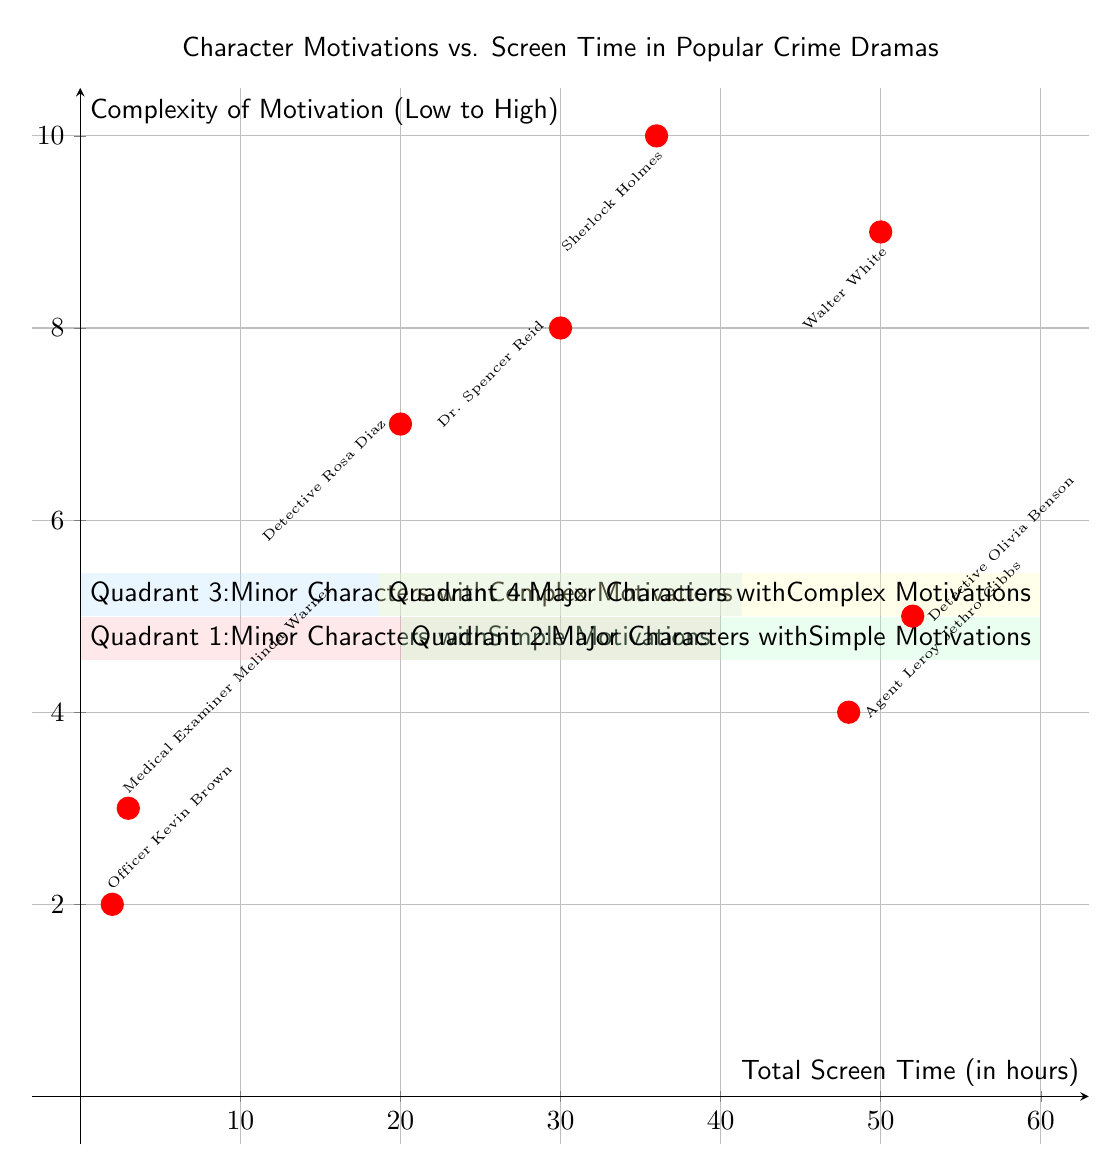What is the total screen time of Walter White? The diagram indicates that Walter White has a screen time of 50 hours, which is represented by the coordinate point associated with his character.
Answer: 50 Which character has the highest complexity of motivation? By examining the y-axis values, Sherlock Holmes is positioned at the highest y-value of 10, which indicates he has the highest complexity of motivation compared to the other characters.
Answer: Sherlock Holmes In which quadrant would you find Detective Olivia Benson? Detective Olivia Benson is located in Quadrant 2, as indicated by the coordinates plotting her total screen time at 52 hours and a complexity of motivation of 5.
Answer: Quadrant 2 How many characters are located in Quadrant 1? Quadrant 1 contains two characters plotted within its area: Officer Kevin Brown and Medical Examiner Melinda Warner, which can be counted directly from the coordinate points in that quadrant.
Answer: 2 Which character has a complexity of motivation rating of 7? By scanning through the y-values of the characters plotted on the diagram, Detective Rosa Diaz is associated with a complexity of motivation rating of 7.
Answer: Detective Rosa Diaz What is the screen time of minor characters with complex motivations? In Quadrant 3, Dr. Spencer Reid at 30 hours and Detective Rosa Diaz at 20 hours represent the minor characters with complex motivations, so the total combined screen time is 50 hours.
Answer: 50 Which quadrant contains major characters with simple motivations? Quadrant 2 is specifically designated for major characters with simple motivations, as indicated by the quadrant title and the positioning of the characters within it.
Answer: Quadrant 2 What character from Quadrant 4 has the lowest screen time? Within Quadrant 4, Walter White and Sherlock Holmes are present, but since Walter White has 50 hours and Sherlock Holmes has 36 hours, the latter has the lowest screen time among the two.
Answer: Sherlock Holmes How many quadrants show minor characters? There are two quadrants showcasing minor characters: Quadrant 1 and Quadrant 3. Both quadrants contain characters who fit into the minor character designation, thus counting them gives us two.
Answer: 2 